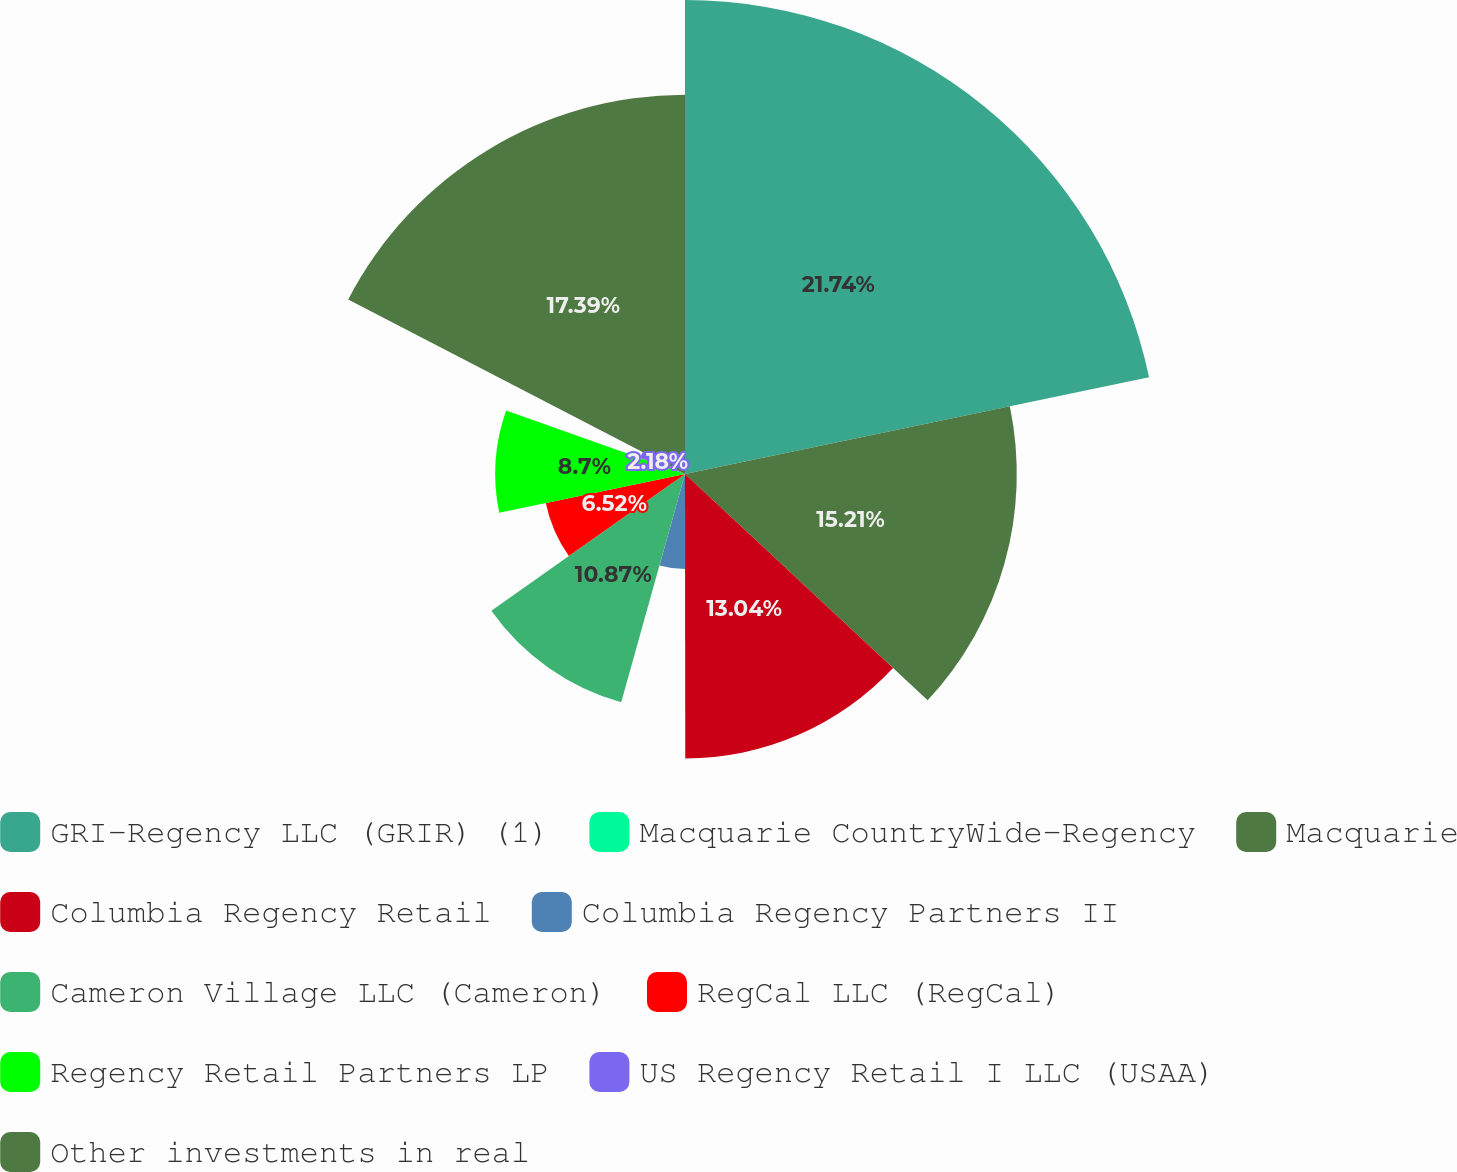Convert chart. <chart><loc_0><loc_0><loc_500><loc_500><pie_chart><fcel>GRI-Regency LLC (GRIR) (1)<fcel>Macquarie CountryWide-Regency<fcel>Macquarie<fcel>Columbia Regency Retail<fcel>Columbia Regency Partners II<fcel>Cameron Village LLC (Cameron)<fcel>RegCal LLC (RegCal)<fcel>Regency Retail Partners LP<fcel>US Regency Retail I LLC (USAA)<fcel>Other investments in real<nl><fcel>21.73%<fcel>0.0%<fcel>15.21%<fcel>13.04%<fcel>4.35%<fcel>10.87%<fcel>6.52%<fcel>8.7%<fcel>2.18%<fcel>17.39%<nl></chart> 